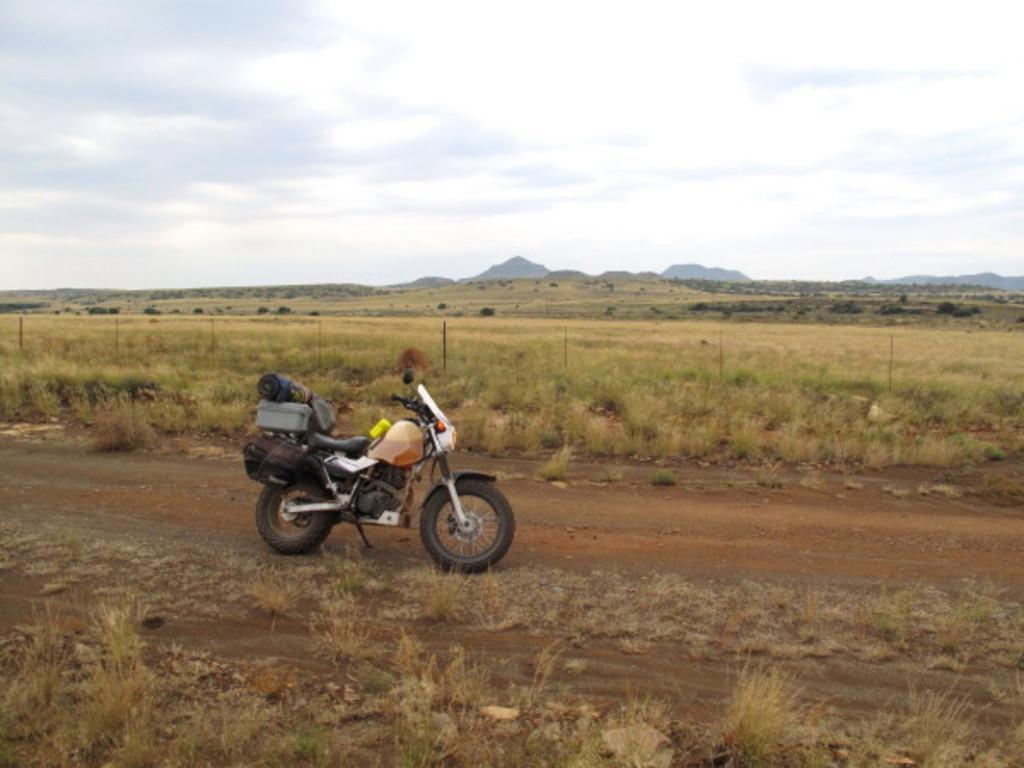In one or two sentences, can you explain what this image depicts? In this picture we can observe a bike parked in this path. There is some dried grass on the ground. In the background there are hills and a sky with clouds. 